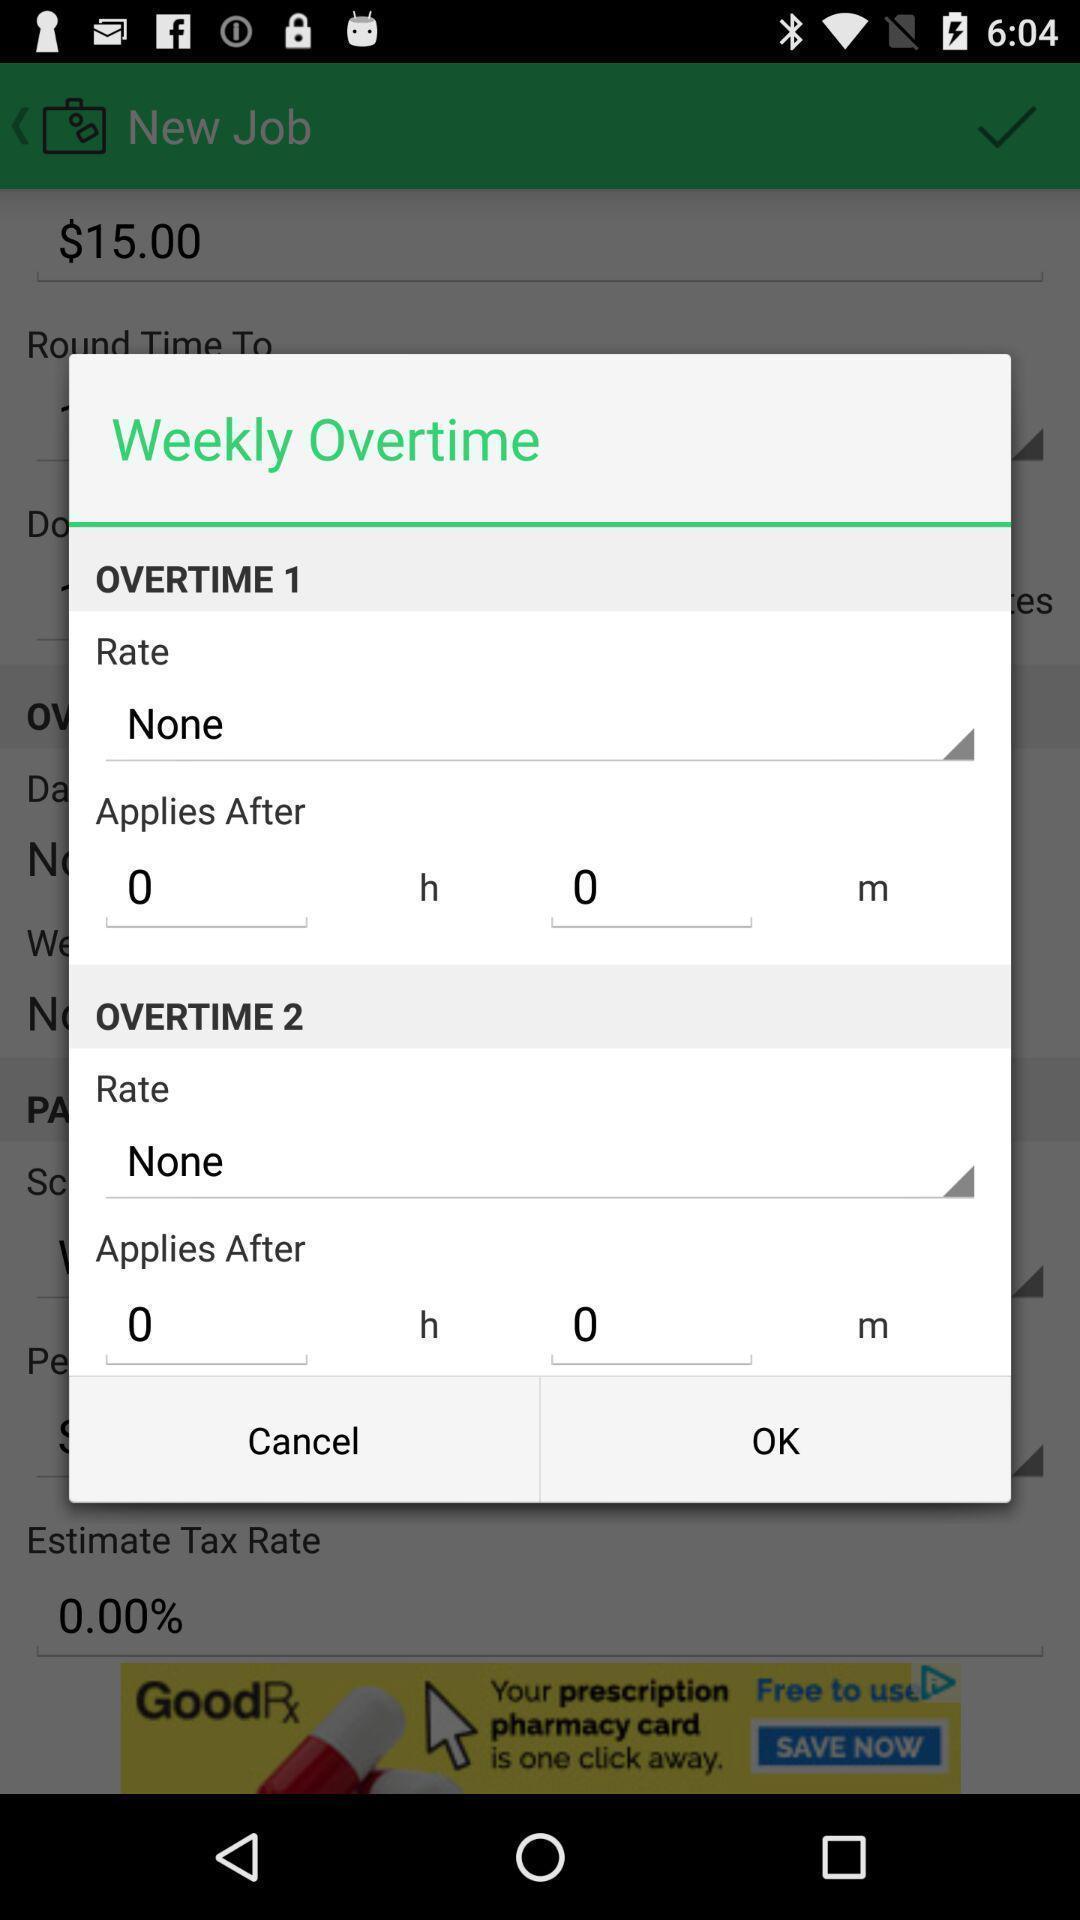Provide a textual representation of this image. Popup of overtime schedule in the application. 